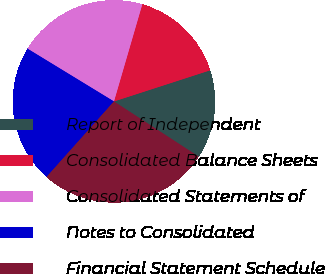Convert chart. <chart><loc_0><loc_0><loc_500><loc_500><pie_chart><fcel>Report of Independent<fcel>Consolidated Balance Sheets<fcel>Consolidated Statements of<fcel>Notes to Consolidated<fcel>Financial Statement Schedule<nl><fcel>14.17%<fcel>15.5%<fcel>20.79%<fcel>22.12%<fcel>27.41%<nl></chart> 